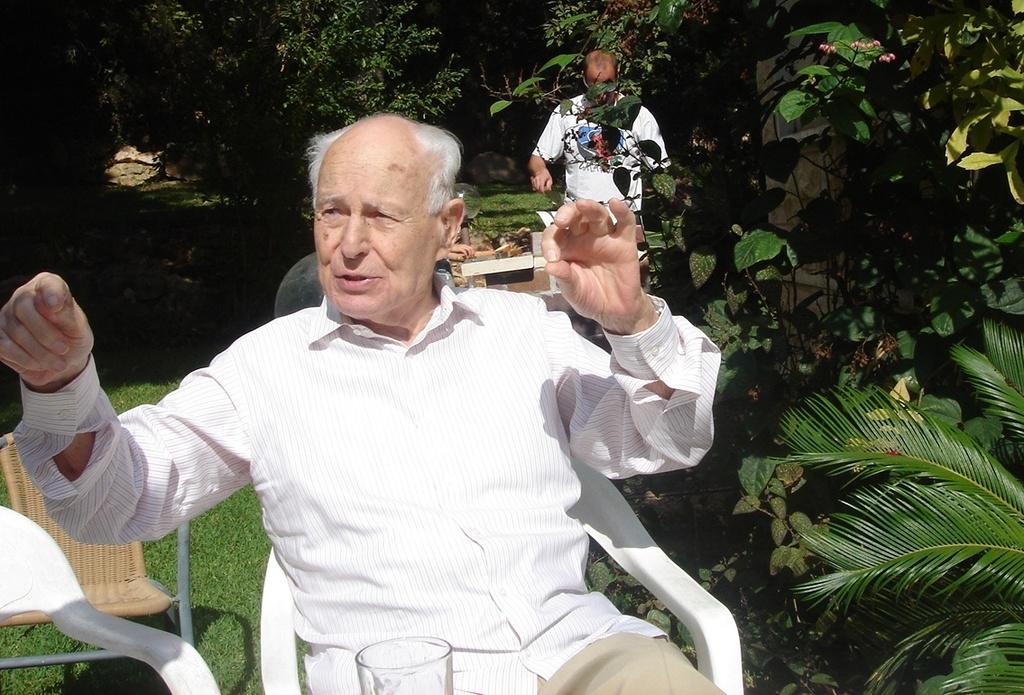In one or two sentences, can you explain what this image depicts? There is a man sitting on a chair. In front of him there is a glass. Also there are chairs. On the right side there are plants. In the back there is another person, trees and some other items. On the ground there is grass. 